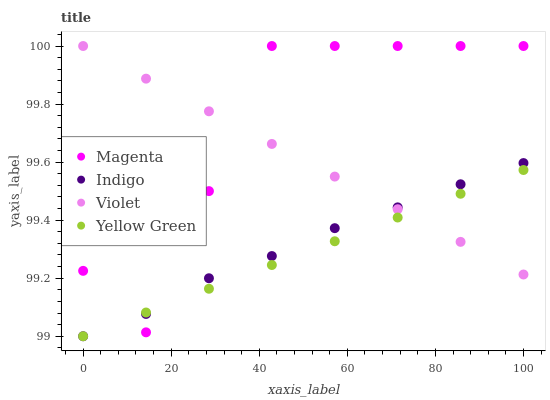Does Yellow Green have the minimum area under the curve?
Answer yes or no. Yes. Does Magenta have the maximum area under the curve?
Answer yes or no. Yes. Does Indigo have the minimum area under the curve?
Answer yes or no. No. Does Indigo have the maximum area under the curve?
Answer yes or no. No. Is Violet the smoothest?
Answer yes or no. Yes. Is Magenta the roughest?
Answer yes or no. Yes. Is Indigo the smoothest?
Answer yes or no. No. Is Indigo the roughest?
Answer yes or no. No. Does Indigo have the lowest value?
Answer yes or no. Yes. Does Violet have the lowest value?
Answer yes or no. No. Does Violet have the highest value?
Answer yes or no. Yes. Does Indigo have the highest value?
Answer yes or no. No. Does Magenta intersect Violet?
Answer yes or no. Yes. Is Magenta less than Violet?
Answer yes or no. No. Is Magenta greater than Violet?
Answer yes or no. No. 